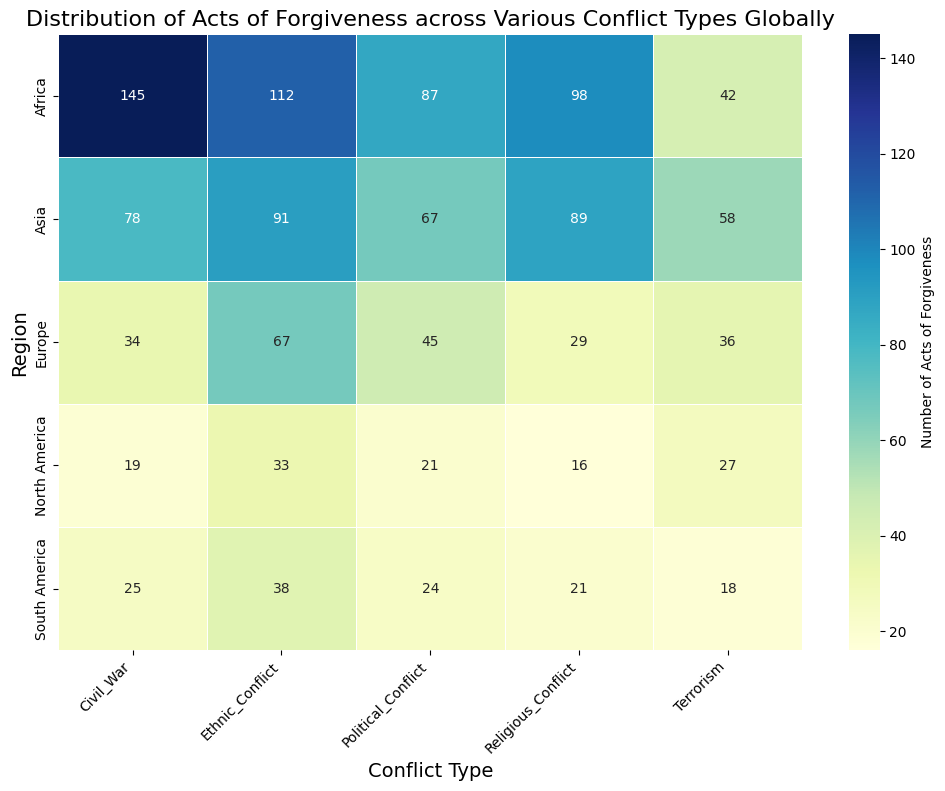Which region has the highest number of acts of forgiveness in Civil War? By examining the color gradient of the heatmap and looking at the numerical annotations in the row for Civil War, we see that Africa has the highest number with 145 acts.
Answer: Africa What is the difference in acts of forgiveness between Civil War and Ethnic Conflict in South America? For Civil War in South America, the number is 25, and for Ethnic Conflict it is 38. Subtracting these two values gives us 38 - 25 = 13.
Answer: 13 Which region has the least number of acts of forgiveness in Religious Conflict? By checking the row for Religious Conflict and comparing the numbers, North America has the lowest value with 16 acts of forgiveness.
Answer: North America How many total acts of forgiveness are there in Europe across all conflict types? Sum the values associated with Europe across all conflict types: 34 (Civil War) + 67 (Ethnic Conflict) + 29 (Religious Conflict) + 45 (Political Conflict) + 36 (Terrorism) = 211.
Answer: 211 In which conflict type does Asia have the highest number of acts of forgiveness, and what is the number? Within the Asia row, we see that Ethnic Conflict has the highest value of 91 acts of forgiveness.
Answer: Ethnic Conflict, 91 Which conflict type shows the most balanced distribution of acts of forgiveness across all regions? By visually examining the heatmap, looking for columns where the color gradient is relatively uniform, we notice that Political Conflict's values are relatively balanced: 87 (Africa), 67 (Asia), 45 (Europe), 21 (North America), 24 (South America).
Answer: Political Conflict What is the combined number of acts of forgiveness for Africa in Civil War and Ethnic Conflict? The number of acts of forgiveness for Africa is 145 in Civil War and 112 in Ethnic Conflict. Adding these together gives 145 + 112 = 257.
Answer: 257 Which region has the highest average number of acts of forgiveness across all conflict types? Calculate the average for each region by summing their values and dividing by 5 (the number of conflict types). Africa has: (145 + 112 + 98 + 87 + 42)/5 = 96.8; Asia has: (78 + 91 + 89 + 67 + 58)/5 = 76.6; Europe has: (34 + 67 + 29 + 45 + 36)/5 = 42.2; North America has: (19 + 33 + 16 + 21 + 27)/5 = 23.2; South America has: (25 + 38 + 21 + 24 + 18)/5 = 25.2. Africa has the highest average of 96.8.
Answer: Africa 